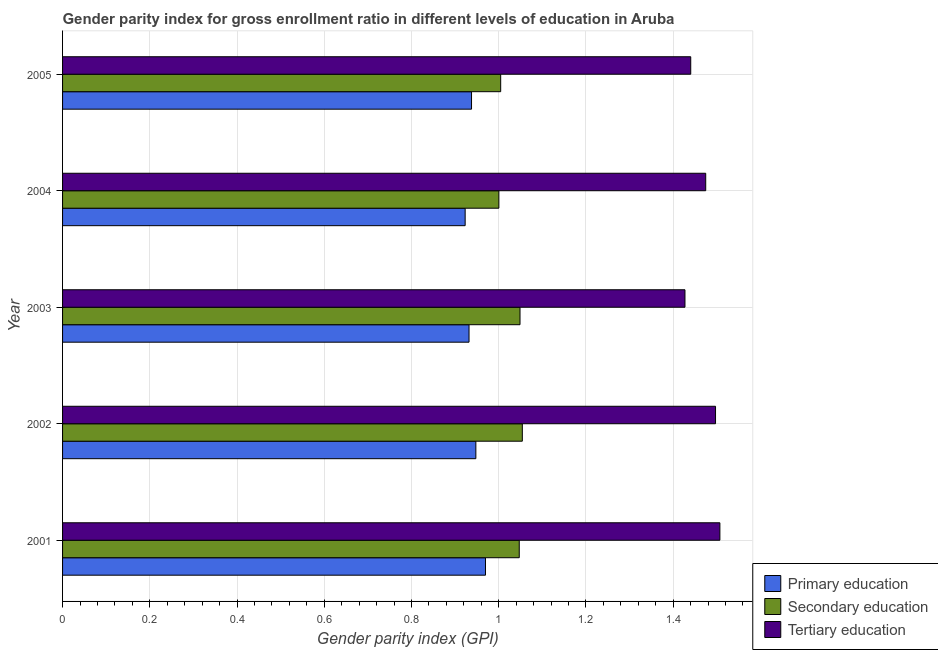Are the number of bars on each tick of the Y-axis equal?
Offer a very short reply. Yes. How many bars are there on the 5th tick from the top?
Provide a short and direct response. 3. How many bars are there on the 5th tick from the bottom?
Give a very brief answer. 3. What is the label of the 1st group of bars from the top?
Provide a short and direct response. 2005. What is the gender parity index in primary education in 2002?
Offer a very short reply. 0.95. Across all years, what is the maximum gender parity index in tertiary education?
Offer a terse response. 1.51. Across all years, what is the minimum gender parity index in primary education?
Ensure brevity in your answer.  0.92. In which year was the gender parity index in primary education maximum?
Ensure brevity in your answer.  2001. In which year was the gender parity index in primary education minimum?
Your answer should be compact. 2004. What is the total gender parity index in primary education in the graph?
Your answer should be very brief. 4.71. What is the difference between the gender parity index in secondary education in 2001 and that in 2004?
Your answer should be very brief. 0.05. What is the difference between the gender parity index in secondary education in 2001 and the gender parity index in tertiary education in 2004?
Ensure brevity in your answer.  -0.43. What is the average gender parity index in tertiary education per year?
Offer a very short reply. 1.47. In the year 2003, what is the difference between the gender parity index in secondary education and gender parity index in primary education?
Give a very brief answer. 0.12. What is the ratio of the gender parity index in tertiary education in 2001 to that in 2003?
Your response must be concise. 1.06. What is the difference between the highest and the second highest gender parity index in primary education?
Keep it short and to the point. 0.02. Is the sum of the gender parity index in primary education in 2001 and 2005 greater than the maximum gender parity index in tertiary education across all years?
Give a very brief answer. Yes. What does the 2nd bar from the top in 2003 represents?
Ensure brevity in your answer.  Secondary education. Is it the case that in every year, the sum of the gender parity index in primary education and gender parity index in secondary education is greater than the gender parity index in tertiary education?
Your response must be concise. Yes. What is the difference between two consecutive major ticks on the X-axis?
Offer a very short reply. 0.2. Does the graph contain grids?
Provide a short and direct response. Yes. How many legend labels are there?
Keep it short and to the point. 3. How are the legend labels stacked?
Provide a succinct answer. Vertical. What is the title of the graph?
Your answer should be compact. Gender parity index for gross enrollment ratio in different levels of education in Aruba. Does "Taxes" appear as one of the legend labels in the graph?
Provide a succinct answer. No. What is the label or title of the X-axis?
Ensure brevity in your answer.  Gender parity index (GPI). What is the Gender parity index (GPI) of Primary education in 2001?
Offer a terse response. 0.97. What is the Gender parity index (GPI) of Secondary education in 2001?
Give a very brief answer. 1.05. What is the Gender parity index (GPI) of Tertiary education in 2001?
Make the answer very short. 1.51. What is the Gender parity index (GPI) of Primary education in 2002?
Offer a very short reply. 0.95. What is the Gender parity index (GPI) in Secondary education in 2002?
Provide a succinct answer. 1.05. What is the Gender parity index (GPI) in Tertiary education in 2002?
Provide a short and direct response. 1.5. What is the Gender parity index (GPI) of Primary education in 2003?
Provide a succinct answer. 0.93. What is the Gender parity index (GPI) of Secondary education in 2003?
Offer a terse response. 1.05. What is the Gender parity index (GPI) of Tertiary education in 2003?
Offer a very short reply. 1.43. What is the Gender parity index (GPI) of Primary education in 2004?
Provide a succinct answer. 0.92. What is the Gender parity index (GPI) in Secondary education in 2004?
Provide a succinct answer. 1. What is the Gender parity index (GPI) of Tertiary education in 2004?
Ensure brevity in your answer.  1.47. What is the Gender parity index (GPI) in Primary education in 2005?
Give a very brief answer. 0.94. What is the Gender parity index (GPI) in Secondary education in 2005?
Offer a very short reply. 1. What is the Gender parity index (GPI) in Tertiary education in 2005?
Offer a very short reply. 1.44. Across all years, what is the maximum Gender parity index (GPI) in Primary education?
Ensure brevity in your answer.  0.97. Across all years, what is the maximum Gender parity index (GPI) in Secondary education?
Provide a short and direct response. 1.05. Across all years, what is the maximum Gender parity index (GPI) in Tertiary education?
Your response must be concise. 1.51. Across all years, what is the minimum Gender parity index (GPI) of Primary education?
Make the answer very short. 0.92. Across all years, what is the minimum Gender parity index (GPI) of Secondary education?
Keep it short and to the point. 1. Across all years, what is the minimum Gender parity index (GPI) in Tertiary education?
Your answer should be compact. 1.43. What is the total Gender parity index (GPI) in Primary education in the graph?
Your answer should be compact. 4.71. What is the total Gender parity index (GPI) of Secondary education in the graph?
Make the answer very short. 5.15. What is the total Gender parity index (GPI) in Tertiary education in the graph?
Provide a short and direct response. 7.35. What is the difference between the Gender parity index (GPI) in Primary education in 2001 and that in 2002?
Provide a succinct answer. 0.02. What is the difference between the Gender parity index (GPI) of Secondary education in 2001 and that in 2002?
Provide a short and direct response. -0.01. What is the difference between the Gender parity index (GPI) of Tertiary education in 2001 and that in 2002?
Keep it short and to the point. 0.01. What is the difference between the Gender parity index (GPI) in Primary education in 2001 and that in 2003?
Your answer should be very brief. 0.04. What is the difference between the Gender parity index (GPI) of Secondary education in 2001 and that in 2003?
Your answer should be very brief. -0. What is the difference between the Gender parity index (GPI) of Tertiary education in 2001 and that in 2003?
Give a very brief answer. 0.08. What is the difference between the Gender parity index (GPI) in Primary education in 2001 and that in 2004?
Offer a terse response. 0.05. What is the difference between the Gender parity index (GPI) of Secondary education in 2001 and that in 2004?
Keep it short and to the point. 0.05. What is the difference between the Gender parity index (GPI) of Tertiary education in 2001 and that in 2004?
Ensure brevity in your answer.  0.03. What is the difference between the Gender parity index (GPI) of Primary education in 2001 and that in 2005?
Provide a succinct answer. 0.03. What is the difference between the Gender parity index (GPI) of Secondary education in 2001 and that in 2005?
Your answer should be very brief. 0.04. What is the difference between the Gender parity index (GPI) in Tertiary education in 2001 and that in 2005?
Provide a short and direct response. 0.07. What is the difference between the Gender parity index (GPI) in Primary education in 2002 and that in 2003?
Keep it short and to the point. 0.02. What is the difference between the Gender parity index (GPI) in Secondary education in 2002 and that in 2003?
Offer a terse response. 0.01. What is the difference between the Gender parity index (GPI) in Tertiary education in 2002 and that in 2003?
Your response must be concise. 0.07. What is the difference between the Gender parity index (GPI) in Primary education in 2002 and that in 2004?
Your answer should be compact. 0.02. What is the difference between the Gender parity index (GPI) of Secondary education in 2002 and that in 2004?
Your answer should be compact. 0.05. What is the difference between the Gender parity index (GPI) of Tertiary education in 2002 and that in 2004?
Your answer should be very brief. 0.02. What is the difference between the Gender parity index (GPI) in Primary education in 2002 and that in 2005?
Your response must be concise. 0.01. What is the difference between the Gender parity index (GPI) in Secondary education in 2002 and that in 2005?
Offer a very short reply. 0.05. What is the difference between the Gender parity index (GPI) in Tertiary education in 2002 and that in 2005?
Make the answer very short. 0.06. What is the difference between the Gender parity index (GPI) of Primary education in 2003 and that in 2004?
Your response must be concise. 0.01. What is the difference between the Gender parity index (GPI) of Secondary education in 2003 and that in 2004?
Keep it short and to the point. 0.05. What is the difference between the Gender parity index (GPI) in Tertiary education in 2003 and that in 2004?
Your answer should be compact. -0.05. What is the difference between the Gender parity index (GPI) in Primary education in 2003 and that in 2005?
Your answer should be very brief. -0.01. What is the difference between the Gender parity index (GPI) in Secondary education in 2003 and that in 2005?
Your response must be concise. 0.04. What is the difference between the Gender parity index (GPI) of Tertiary education in 2003 and that in 2005?
Provide a short and direct response. -0.01. What is the difference between the Gender parity index (GPI) in Primary education in 2004 and that in 2005?
Offer a terse response. -0.01. What is the difference between the Gender parity index (GPI) of Secondary education in 2004 and that in 2005?
Keep it short and to the point. -0. What is the difference between the Gender parity index (GPI) of Tertiary education in 2004 and that in 2005?
Keep it short and to the point. 0.03. What is the difference between the Gender parity index (GPI) of Primary education in 2001 and the Gender parity index (GPI) of Secondary education in 2002?
Keep it short and to the point. -0.08. What is the difference between the Gender parity index (GPI) in Primary education in 2001 and the Gender parity index (GPI) in Tertiary education in 2002?
Offer a terse response. -0.53. What is the difference between the Gender parity index (GPI) of Secondary education in 2001 and the Gender parity index (GPI) of Tertiary education in 2002?
Offer a very short reply. -0.45. What is the difference between the Gender parity index (GPI) of Primary education in 2001 and the Gender parity index (GPI) of Secondary education in 2003?
Offer a very short reply. -0.08. What is the difference between the Gender parity index (GPI) of Primary education in 2001 and the Gender parity index (GPI) of Tertiary education in 2003?
Offer a terse response. -0.46. What is the difference between the Gender parity index (GPI) of Secondary education in 2001 and the Gender parity index (GPI) of Tertiary education in 2003?
Your response must be concise. -0.38. What is the difference between the Gender parity index (GPI) in Primary education in 2001 and the Gender parity index (GPI) in Secondary education in 2004?
Offer a terse response. -0.03. What is the difference between the Gender parity index (GPI) of Primary education in 2001 and the Gender parity index (GPI) of Tertiary education in 2004?
Give a very brief answer. -0.5. What is the difference between the Gender parity index (GPI) in Secondary education in 2001 and the Gender parity index (GPI) in Tertiary education in 2004?
Give a very brief answer. -0.43. What is the difference between the Gender parity index (GPI) of Primary education in 2001 and the Gender parity index (GPI) of Secondary education in 2005?
Offer a terse response. -0.03. What is the difference between the Gender parity index (GPI) of Primary education in 2001 and the Gender parity index (GPI) of Tertiary education in 2005?
Provide a succinct answer. -0.47. What is the difference between the Gender parity index (GPI) of Secondary education in 2001 and the Gender parity index (GPI) of Tertiary education in 2005?
Give a very brief answer. -0.39. What is the difference between the Gender parity index (GPI) in Primary education in 2002 and the Gender parity index (GPI) in Secondary education in 2003?
Your answer should be compact. -0.1. What is the difference between the Gender parity index (GPI) of Primary education in 2002 and the Gender parity index (GPI) of Tertiary education in 2003?
Keep it short and to the point. -0.48. What is the difference between the Gender parity index (GPI) of Secondary education in 2002 and the Gender parity index (GPI) of Tertiary education in 2003?
Your response must be concise. -0.37. What is the difference between the Gender parity index (GPI) in Primary education in 2002 and the Gender parity index (GPI) in Secondary education in 2004?
Give a very brief answer. -0.05. What is the difference between the Gender parity index (GPI) of Primary education in 2002 and the Gender parity index (GPI) of Tertiary education in 2004?
Your answer should be compact. -0.53. What is the difference between the Gender parity index (GPI) in Secondary education in 2002 and the Gender parity index (GPI) in Tertiary education in 2004?
Keep it short and to the point. -0.42. What is the difference between the Gender parity index (GPI) in Primary education in 2002 and the Gender parity index (GPI) in Secondary education in 2005?
Offer a terse response. -0.06. What is the difference between the Gender parity index (GPI) in Primary education in 2002 and the Gender parity index (GPI) in Tertiary education in 2005?
Your answer should be very brief. -0.49. What is the difference between the Gender parity index (GPI) of Secondary education in 2002 and the Gender parity index (GPI) of Tertiary education in 2005?
Your answer should be compact. -0.39. What is the difference between the Gender parity index (GPI) of Primary education in 2003 and the Gender parity index (GPI) of Secondary education in 2004?
Provide a short and direct response. -0.07. What is the difference between the Gender parity index (GPI) in Primary education in 2003 and the Gender parity index (GPI) in Tertiary education in 2004?
Offer a terse response. -0.54. What is the difference between the Gender parity index (GPI) in Secondary education in 2003 and the Gender parity index (GPI) in Tertiary education in 2004?
Provide a succinct answer. -0.43. What is the difference between the Gender parity index (GPI) in Primary education in 2003 and the Gender parity index (GPI) in Secondary education in 2005?
Your response must be concise. -0.07. What is the difference between the Gender parity index (GPI) in Primary education in 2003 and the Gender parity index (GPI) in Tertiary education in 2005?
Ensure brevity in your answer.  -0.51. What is the difference between the Gender parity index (GPI) in Secondary education in 2003 and the Gender parity index (GPI) in Tertiary education in 2005?
Keep it short and to the point. -0.39. What is the difference between the Gender parity index (GPI) in Primary education in 2004 and the Gender parity index (GPI) in Secondary education in 2005?
Keep it short and to the point. -0.08. What is the difference between the Gender parity index (GPI) of Primary education in 2004 and the Gender parity index (GPI) of Tertiary education in 2005?
Your response must be concise. -0.52. What is the difference between the Gender parity index (GPI) in Secondary education in 2004 and the Gender parity index (GPI) in Tertiary education in 2005?
Give a very brief answer. -0.44. What is the average Gender parity index (GPI) of Primary education per year?
Ensure brevity in your answer.  0.94. What is the average Gender parity index (GPI) in Secondary education per year?
Keep it short and to the point. 1.03. What is the average Gender parity index (GPI) in Tertiary education per year?
Provide a succinct answer. 1.47. In the year 2001, what is the difference between the Gender parity index (GPI) in Primary education and Gender parity index (GPI) in Secondary education?
Make the answer very short. -0.08. In the year 2001, what is the difference between the Gender parity index (GPI) in Primary education and Gender parity index (GPI) in Tertiary education?
Your answer should be very brief. -0.54. In the year 2001, what is the difference between the Gender parity index (GPI) of Secondary education and Gender parity index (GPI) of Tertiary education?
Give a very brief answer. -0.46. In the year 2002, what is the difference between the Gender parity index (GPI) in Primary education and Gender parity index (GPI) in Secondary education?
Offer a very short reply. -0.11. In the year 2002, what is the difference between the Gender parity index (GPI) in Primary education and Gender parity index (GPI) in Tertiary education?
Give a very brief answer. -0.55. In the year 2002, what is the difference between the Gender parity index (GPI) of Secondary education and Gender parity index (GPI) of Tertiary education?
Keep it short and to the point. -0.44. In the year 2003, what is the difference between the Gender parity index (GPI) in Primary education and Gender parity index (GPI) in Secondary education?
Give a very brief answer. -0.12. In the year 2003, what is the difference between the Gender parity index (GPI) in Primary education and Gender parity index (GPI) in Tertiary education?
Offer a very short reply. -0.5. In the year 2003, what is the difference between the Gender parity index (GPI) of Secondary education and Gender parity index (GPI) of Tertiary education?
Keep it short and to the point. -0.38. In the year 2004, what is the difference between the Gender parity index (GPI) in Primary education and Gender parity index (GPI) in Secondary education?
Make the answer very short. -0.08. In the year 2004, what is the difference between the Gender parity index (GPI) of Primary education and Gender parity index (GPI) of Tertiary education?
Provide a short and direct response. -0.55. In the year 2004, what is the difference between the Gender parity index (GPI) in Secondary education and Gender parity index (GPI) in Tertiary education?
Your response must be concise. -0.47. In the year 2005, what is the difference between the Gender parity index (GPI) of Primary education and Gender parity index (GPI) of Secondary education?
Offer a terse response. -0.07. In the year 2005, what is the difference between the Gender parity index (GPI) of Primary education and Gender parity index (GPI) of Tertiary education?
Your answer should be compact. -0.5. In the year 2005, what is the difference between the Gender parity index (GPI) in Secondary education and Gender parity index (GPI) in Tertiary education?
Your answer should be very brief. -0.44. What is the ratio of the Gender parity index (GPI) in Primary education in 2001 to that in 2002?
Offer a terse response. 1.02. What is the ratio of the Gender parity index (GPI) in Primary education in 2001 to that in 2003?
Your answer should be compact. 1.04. What is the ratio of the Gender parity index (GPI) of Secondary education in 2001 to that in 2003?
Your answer should be compact. 1. What is the ratio of the Gender parity index (GPI) of Tertiary education in 2001 to that in 2003?
Give a very brief answer. 1.06. What is the ratio of the Gender parity index (GPI) in Primary education in 2001 to that in 2004?
Your answer should be compact. 1.05. What is the ratio of the Gender parity index (GPI) of Secondary education in 2001 to that in 2004?
Give a very brief answer. 1.05. What is the ratio of the Gender parity index (GPI) of Tertiary education in 2001 to that in 2004?
Make the answer very short. 1.02. What is the ratio of the Gender parity index (GPI) of Primary education in 2001 to that in 2005?
Make the answer very short. 1.03. What is the ratio of the Gender parity index (GPI) of Secondary education in 2001 to that in 2005?
Offer a terse response. 1.04. What is the ratio of the Gender parity index (GPI) of Tertiary education in 2001 to that in 2005?
Ensure brevity in your answer.  1.05. What is the ratio of the Gender parity index (GPI) in Primary education in 2002 to that in 2003?
Make the answer very short. 1.02. What is the ratio of the Gender parity index (GPI) in Tertiary education in 2002 to that in 2003?
Your response must be concise. 1.05. What is the ratio of the Gender parity index (GPI) of Primary education in 2002 to that in 2004?
Keep it short and to the point. 1.03. What is the ratio of the Gender parity index (GPI) in Secondary education in 2002 to that in 2004?
Your answer should be compact. 1.05. What is the ratio of the Gender parity index (GPI) in Tertiary education in 2002 to that in 2004?
Provide a succinct answer. 1.02. What is the ratio of the Gender parity index (GPI) in Primary education in 2002 to that in 2005?
Your answer should be compact. 1.01. What is the ratio of the Gender parity index (GPI) of Secondary education in 2002 to that in 2005?
Offer a terse response. 1.05. What is the ratio of the Gender parity index (GPI) in Tertiary education in 2002 to that in 2005?
Provide a succinct answer. 1.04. What is the ratio of the Gender parity index (GPI) of Primary education in 2003 to that in 2004?
Make the answer very short. 1.01. What is the ratio of the Gender parity index (GPI) of Secondary education in 2003 to that in 2004?
Give a very brief answer. 1.05. What is the ratio of the Gender parity index (GPI) of Primary education in 2003 to that in 2005?
Provide a short and direct response. 0.99. What is the ratio of the Gender parity index (GPI) of Secondary education in 2003 to that in 2005?
Your response must be concise. 1.04. What is the ratio of the Gender parity index (GPI) in Tertiary education in 2003 to that in 2005?
Your answer should be compact. 0.99. What is the ratio of the Gender parity index (GPI) in Primary education in 2004 to that in 2005?
Ensure brevity in your answer.  0.98. What is the ratio of the Gender parity index (GPI) of Secondary education in 2004 to that in 2005?
Your answer should be compact. 1. What is the ratio of the Gender parity index (GPI) of Tertiary education in 2004 to that in 2005?
Provide a short and direct response. 1.02. What is the difference between the highest and the second highest Gender parity index (GPI) of Primary education?
Your response must be concise. 0.02. What is the difference between the highest and the second highest Gender parity index (GPI) in Secondary education?
Your response must be concise. 0.01. What is the difference between the highest and the second highest Gender parity index (GPI) of Tertiary education?
Provide a succinct answer. 0.01. What is the difference between the highest and the lowest Gender parity index (GPI) in Primary education?
Provide a succinct answer. 0.05. What is the difference between the highest and the lowest Gender parity index (GPI) in Secondary education?
Your response must be concise. 0.05. What is the difference between the highest and the lowest Gender parity index (GPI) in Tertiary education?
Your answer should be very brief. 0.08. 